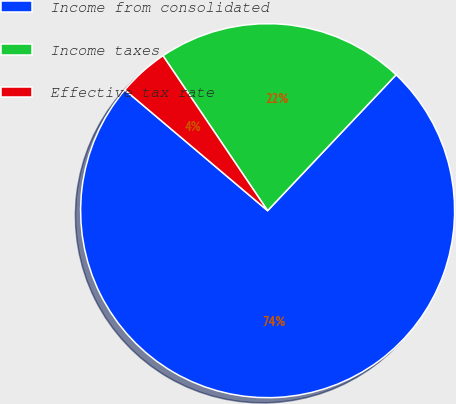Convert chart. <chart><loc_0><loc_0><loc_500><loc_500><pie_chart><fcel>Income from consolidated<fcel>Income taxes<fcel>Effective tax rate<nl><fcel>74.12%<fcel>21.51%<fcel>4.37%<nl></chart> 